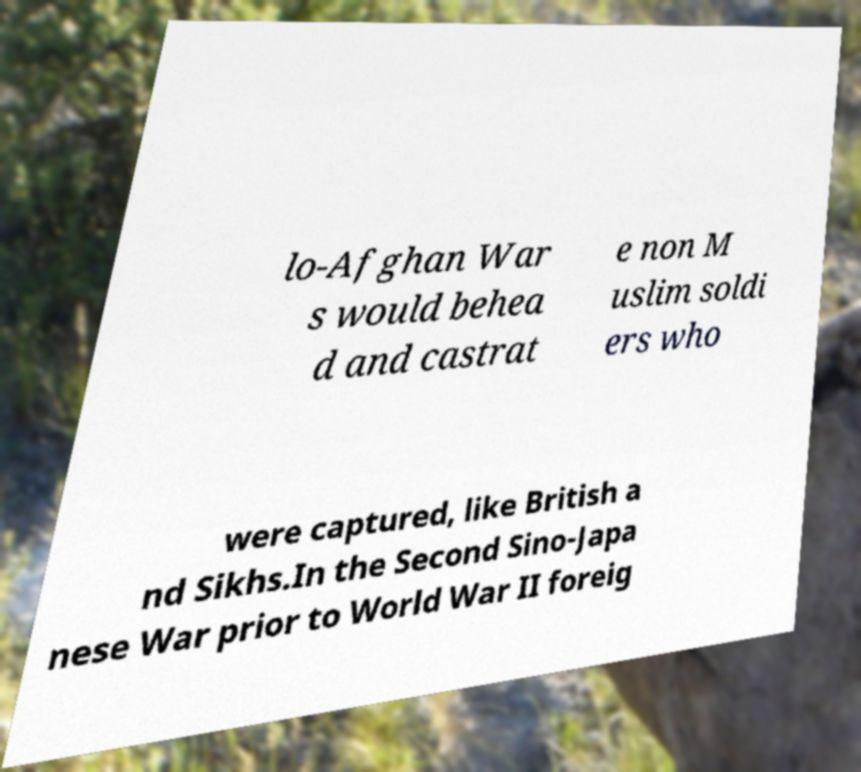Please read and relay the text visible in this image. What does it say? lo-Afghan War s would behea d and castrat e non M uslim soldi ers who were captured, like British a nd Sikhs.In the Second Sino-Japa nese War prior to World War II foreig 